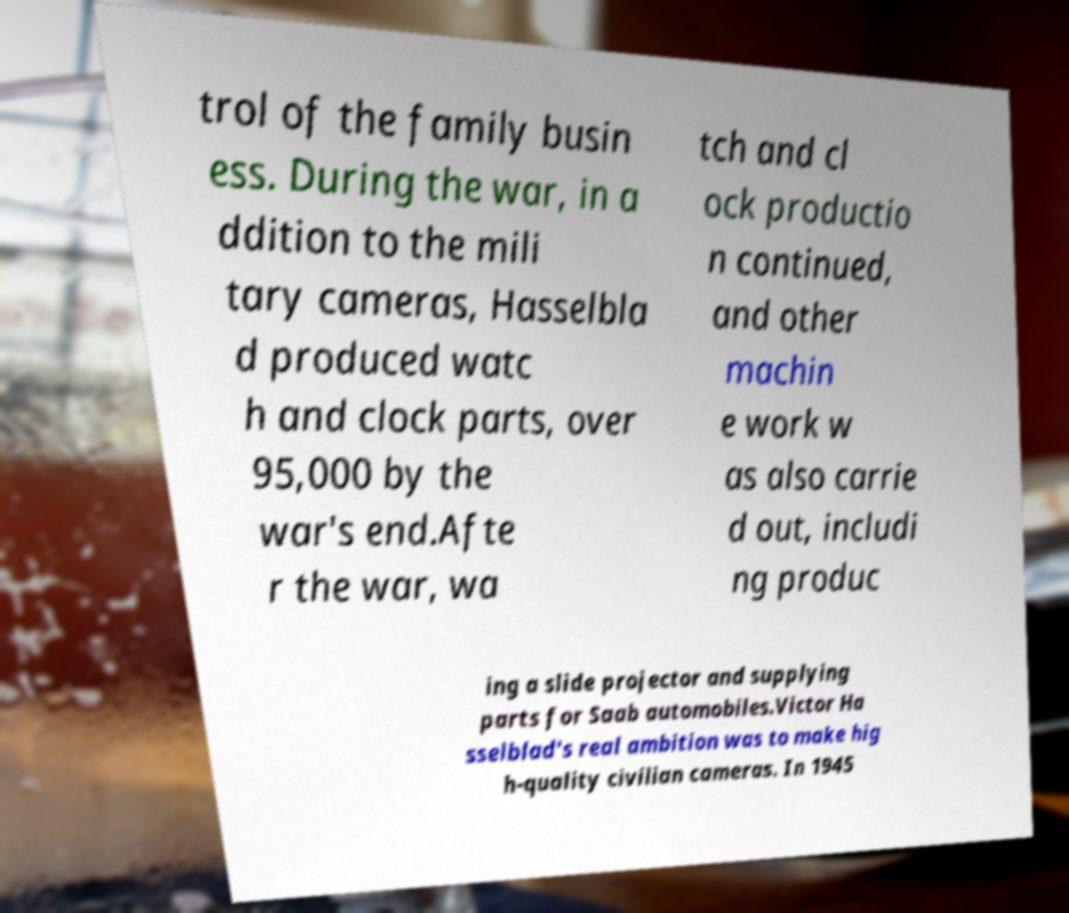Can you read and provide the text displayed in the image?This photo seems to have some interesting text. Can you extract and type it out for me? trol of the family busin ess. During the war, in a ddition to the mili tary cameras, Hasselbla d produced watc h and clock parts, over 95,000 by the war's end.Afte r the war, wa tch and cl ock productio n continued, and other machin e work w as also carrie d out, includi ng produc ing a slide projector and supplying parts for Saab automobiles.Victor Ha sselblad's real ambition was to make hig h-quality civilian cameras. In 1945 